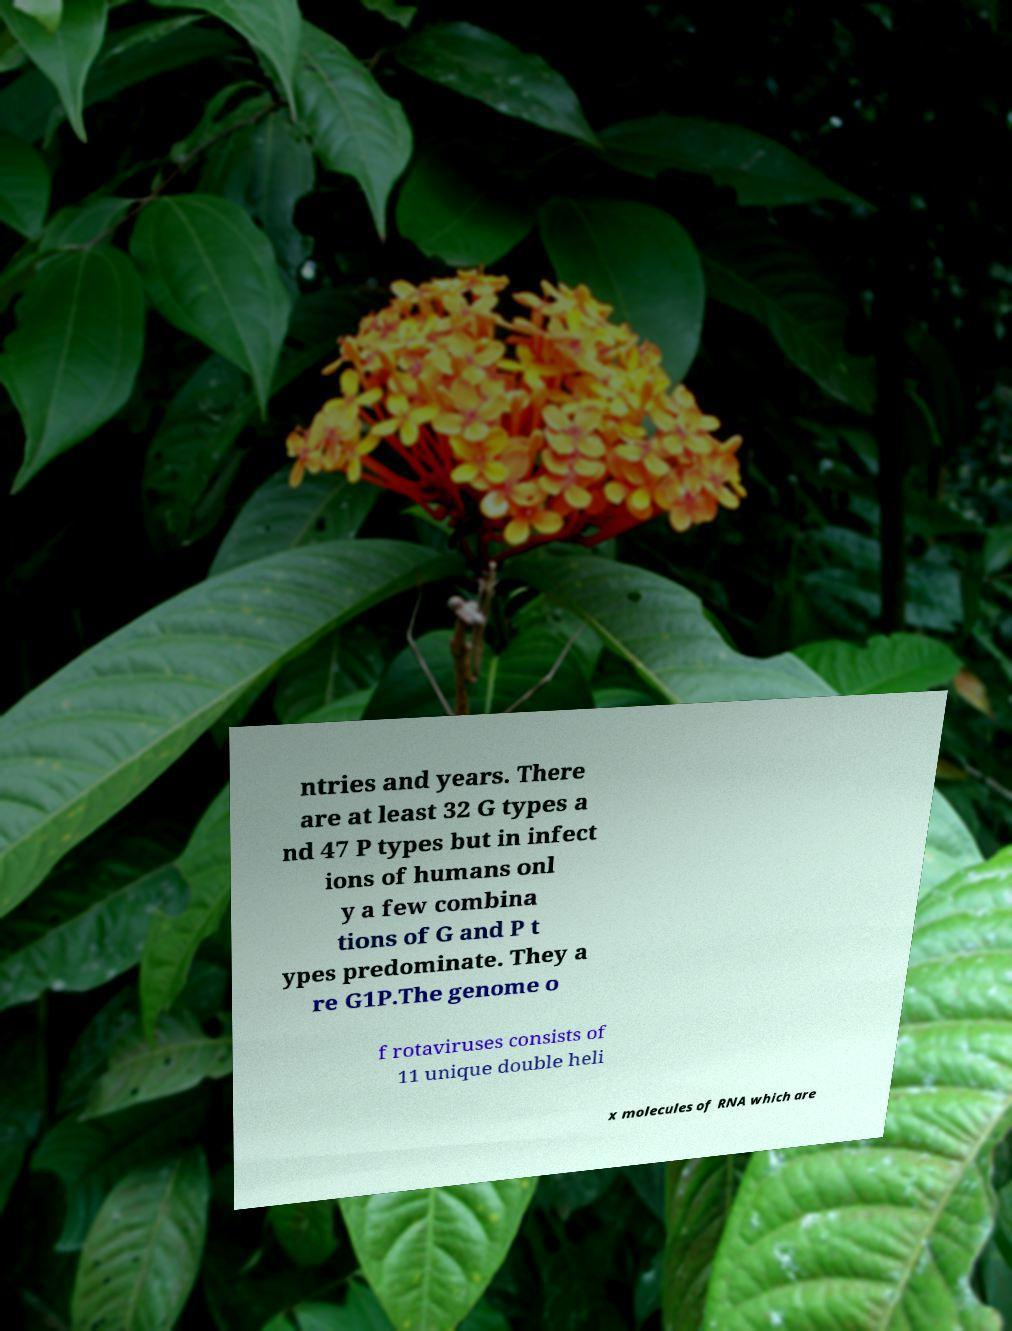Can you accurately transcribe the text from the provided image for me? ntries and years. There are at least 32 G types a nd 47 P types but in infect ions of humans onl y a few combina tions of G and P t ypes predominate. They a re G1P.The genome o f rotaviruses consists of 11 unique double heli x molecules of RNA which are 